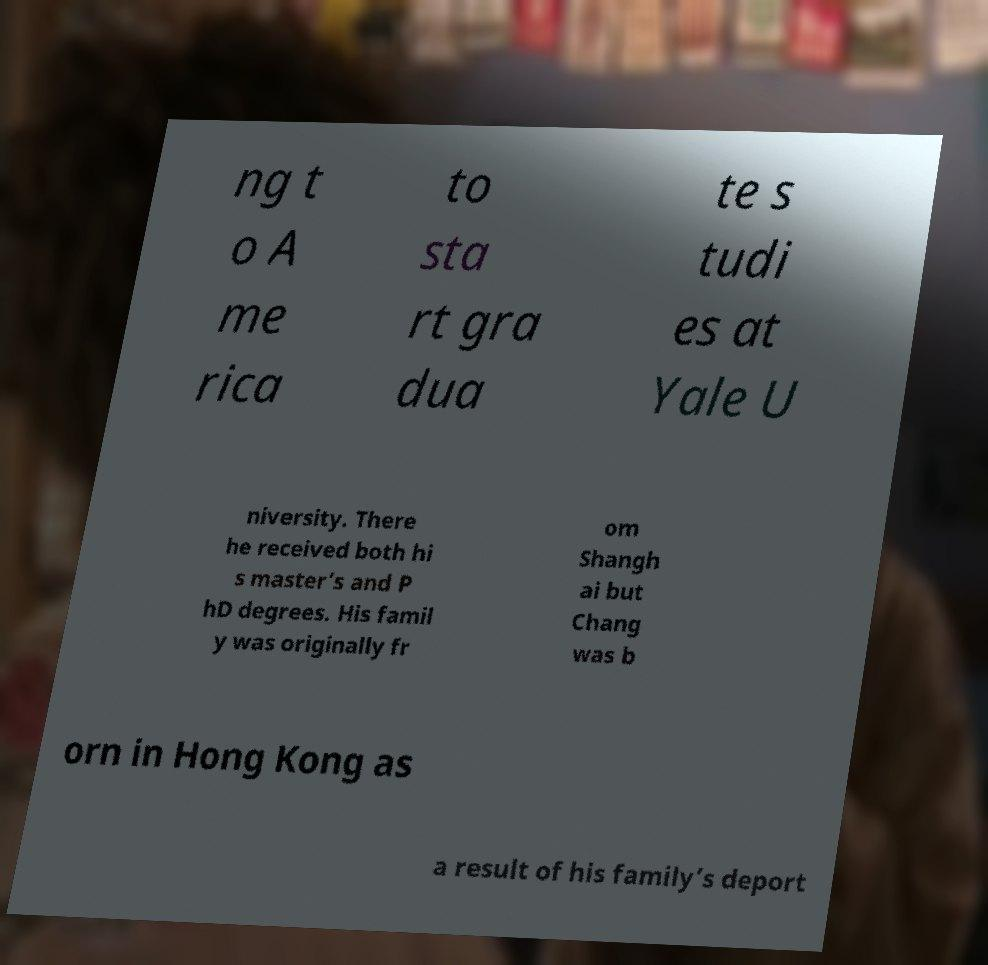For documentation purposes, I need the text within this image transcribed. Could you provide that? ng t o A me rica to sta rt gra dua te s tudi es at Yale U niversity. There he received both hi s master’s and P hD degrees. His famil y was originally fr om Shangh ai but Chang was b orn in Hong Kong as a result of his family’s deport 